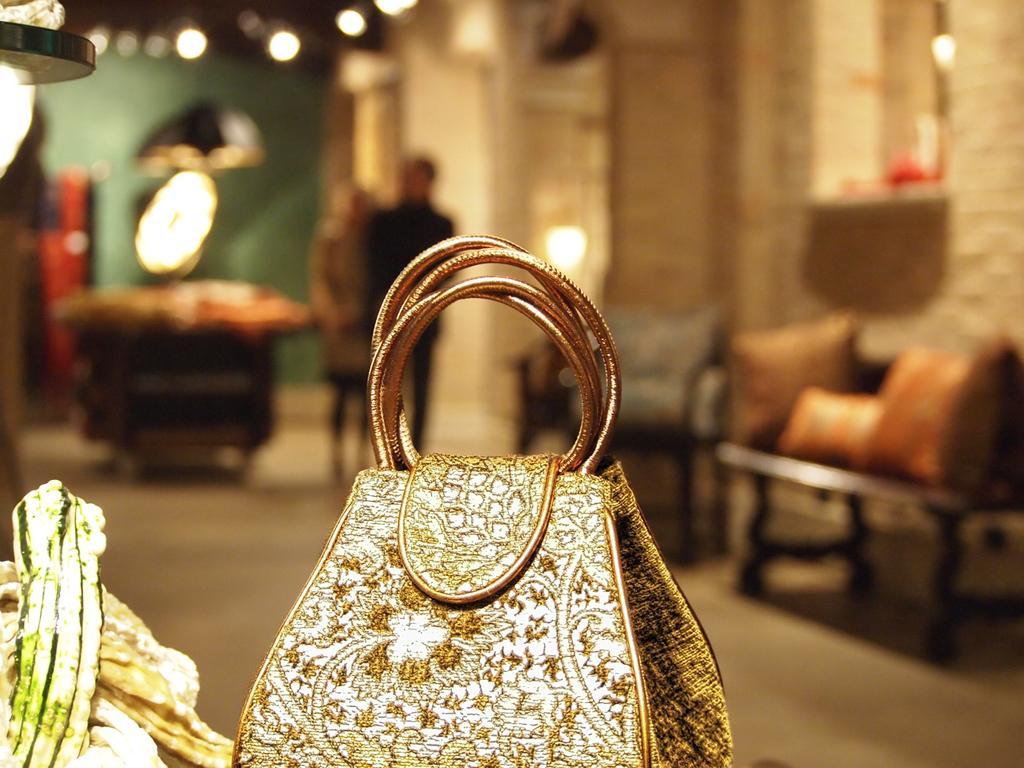Describe this image in one or two sentences. In this image I see a handbag in front. In the background I see many lights, a sofa set, 2 persons and the wall. 